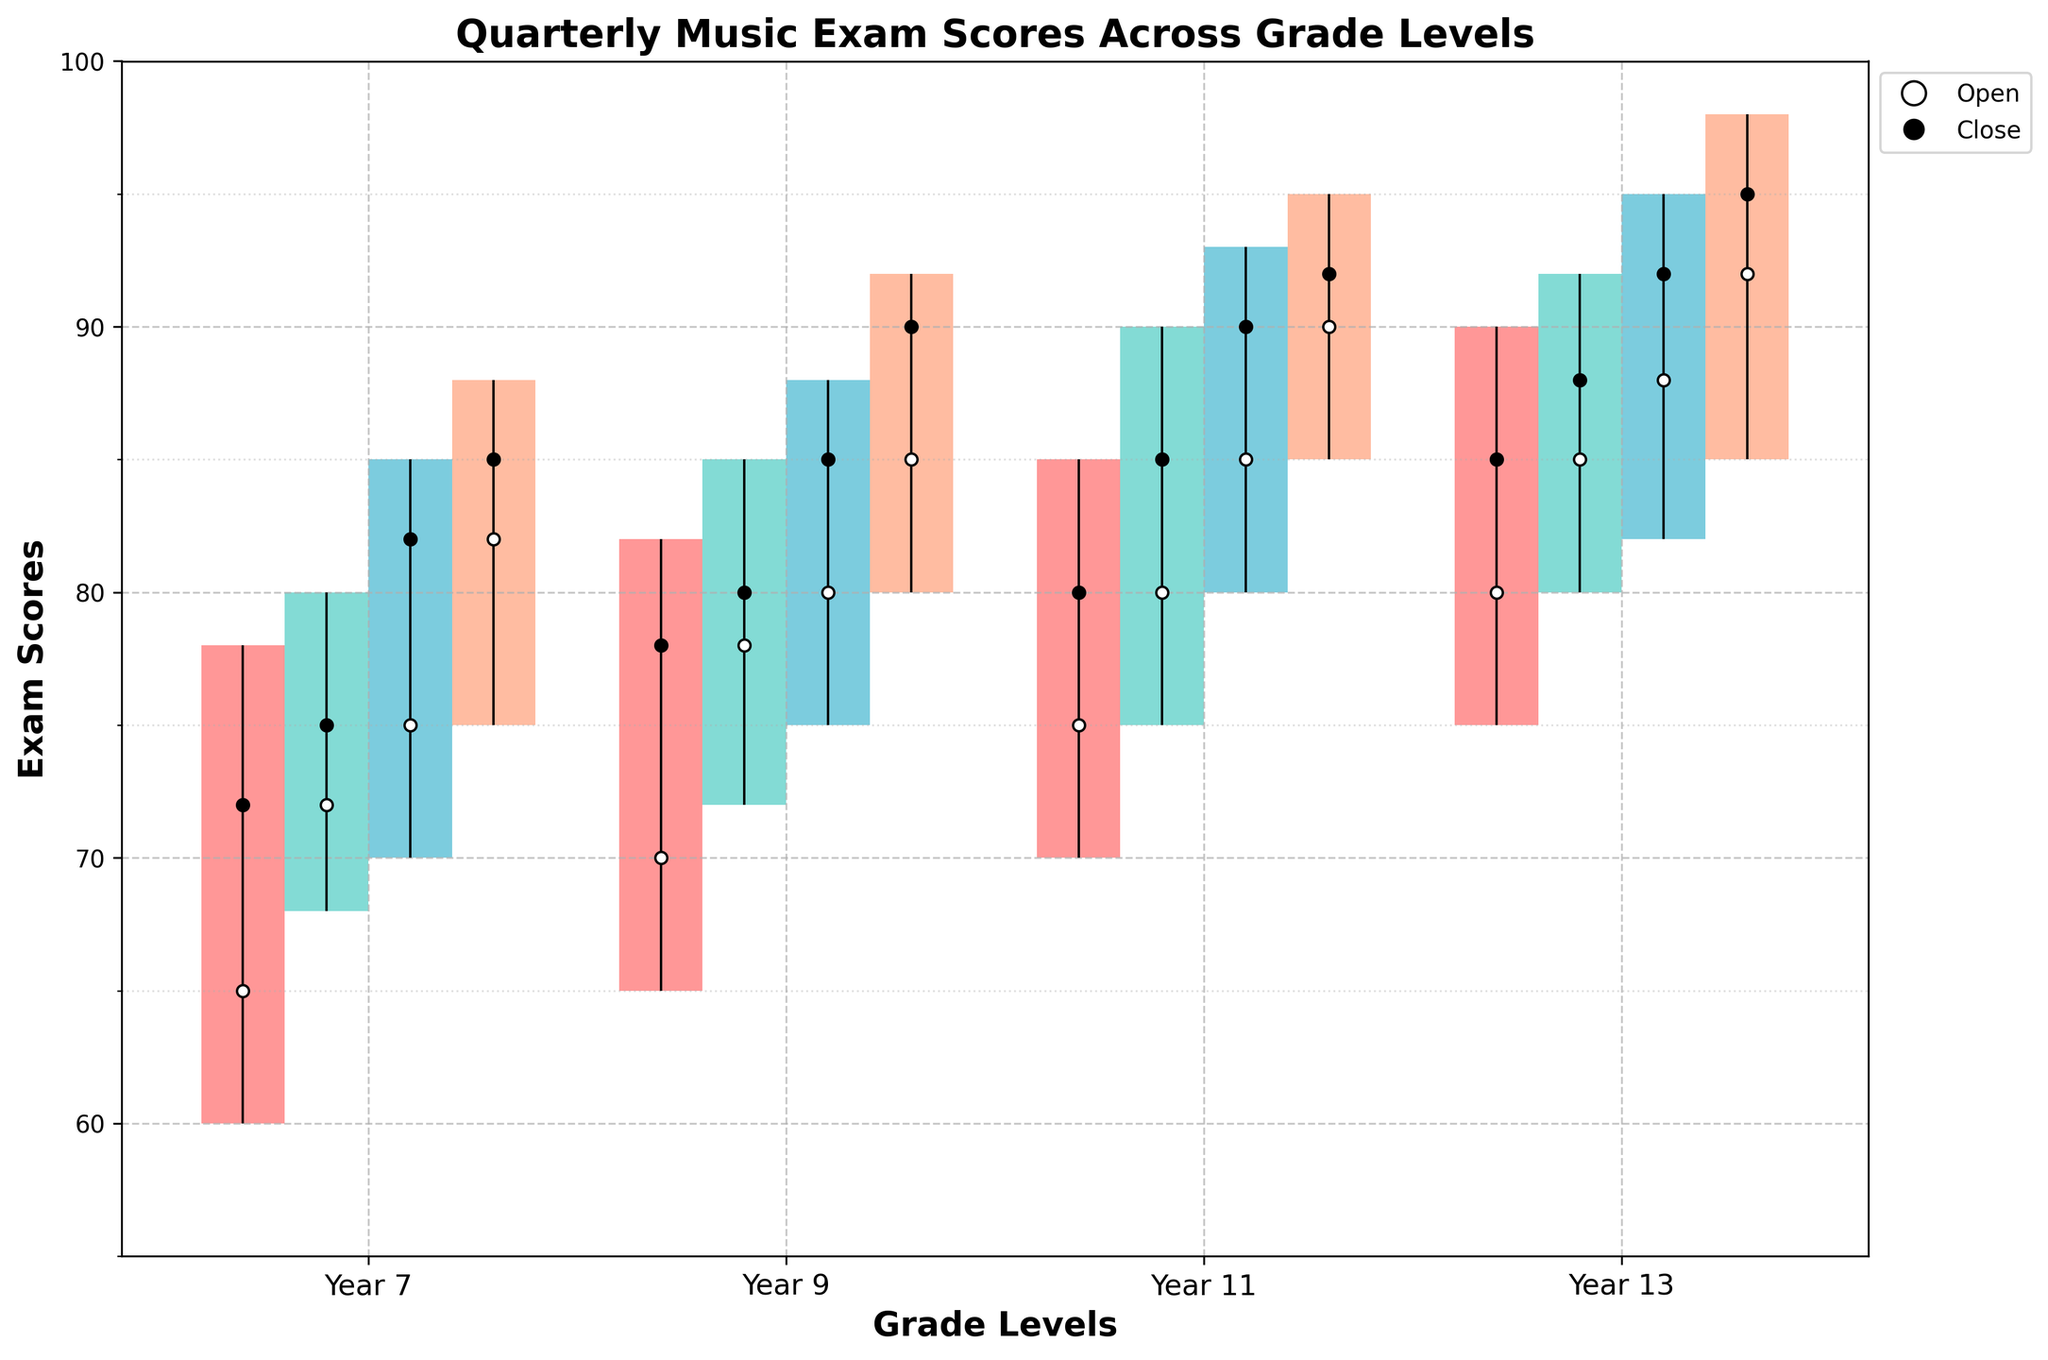What's the title of the chart? The title of the chart is typically located at the top center of the figure. In this case, the title is explicitly given in the code.
Answer: Quarterly Music Exam Scores Across Grade Levels How many grades are displayed in the chart? The x-axis labels represent different grade levels. By counting these labels, we find that there are 4 grades displayed: Year 7, Year 9, Year 11, and Year 13.
Answer: 4 What are the colors used to represent each quarter? The colors for each quarter are identified by looking at the visual elements in the chart or legend. According to the code: Q1 is a shade of red, Q2 is a mint green, Q3 is a bluish color, and Q4 is salmon pink.
Answer: Red, Mint Green, Blue, Salmon Pink Which grade has the highest closing score in Q4? To determine this, look at the closing score for each grade in Q4, indicated by a black dot at the top of the corresponding bar. For Year 13 in Q4, the closing score is 95, which is the highest.
Answer: Year 13 What is the range of scores for Year 9 in Q2? The range can be calculated by subtracting the lowest score (low) from the highest score (high) for Year 9 in Q2. High = 85, Low = 72: 85 - 72 = 13.
Answer: 13 Which grade shows the largest improvement in closing scores from Q1 to Q4? Calculate the difference in closing scores between Q4 and Q1 for each grade and compare them. Year 7: 85 - 72 = 13; Year 9: 90 - 78 = 12; Year 11: 92 - 80 = 12; Year 13: 95 - 85 = 10. Year 7 shows the largest improvement of 13 points.
Answer: Year 7 On average, which grade had the highest opening scores across all quarters? Calculate the average opening scores for each grade by summing their opening scores across all quarters and dividing by 4. Year 7: (65 + 72 + 75 + 82) / 4 = 73.5; Year 9: (70 + 78 + 80 + 85) / 4 = 78.25; Year 11: (75 + 80 + 85 + 90) / 4 = 82.5; Year 13: (80 + 85 + 88 + 92) / 4 = 86.25. The highest average opening score is 86.25 for Year 13.
Answer: Year 13 What is the median closing score for Year 11 across all quarters? List the closing scores for Year 11 (80, 85, 90, 92) in ascending order and find the median, which is the average of the two middle numbers: (85 + 90) / 2 = 87.5.
Answer: 87.5 Which quarter shows the greatest variability in scores for Year 7? The variability in scores can be observed by looking at the range (high minus low) for each quarter in Year 7. Q1: 78-60 = 18; Q2: 80-68 = 12; Q3: 85-70 = 15; Q4: 88-75 = 13. The greatest variability is in Q1 with a range of 18 points.
Answer: Q1 How does the closing score trend for Year 9 change across quarters? Observe the closing scores for Year 9 across Q1 to Q4. The scores are 78, 80, 85, and 90, showing a consistent increasing trend.
Answer: Increasing 